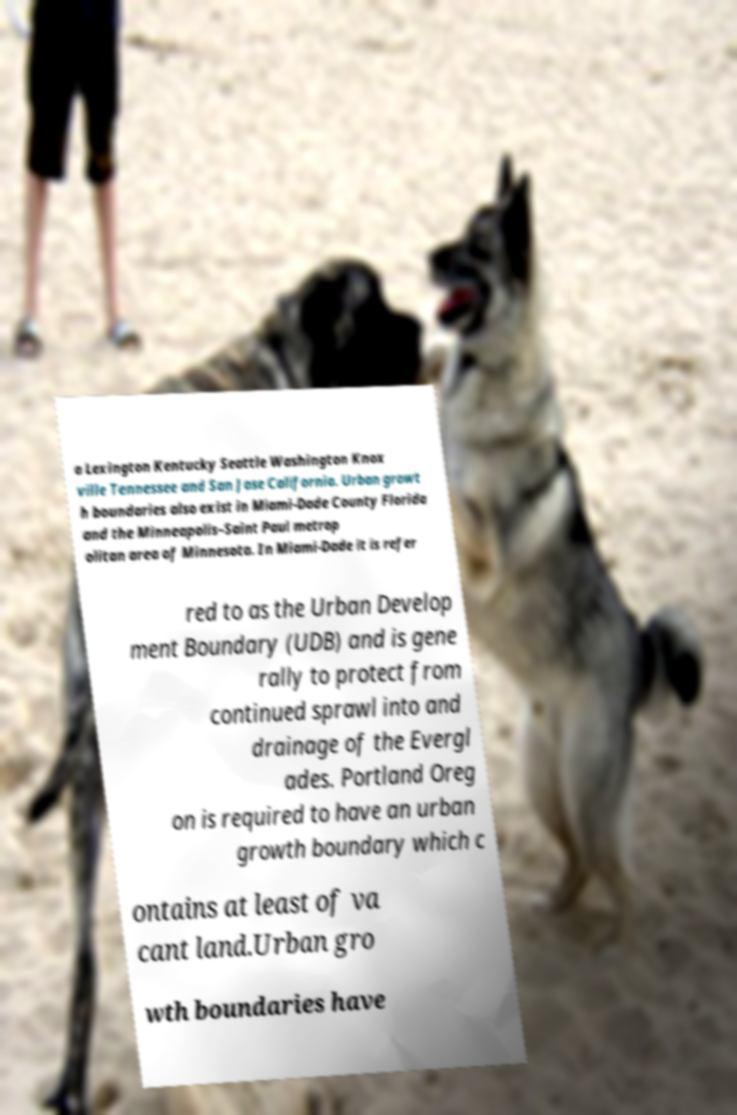Could you assist in decoding the text presented in this image and type it out clearly? a Lexington Kentucky Seattle Washington Knox ville Tennessee and San Jose California. Urban growt h boundaries also exist in Miami-Dade County Florida and the Minneapolis–Saint Paul metrop olitan area of Minnesota. In Miami-Dade it is refer red to as the Urban Develop ment Boundary (UDB) and is gene rally to protect from continued sprawl into and drainage of the Evergl ades. Portland Oreg on is required to have an urban growth boundary which c ontains at least of va cant land.Urban gro wth boundaries have 